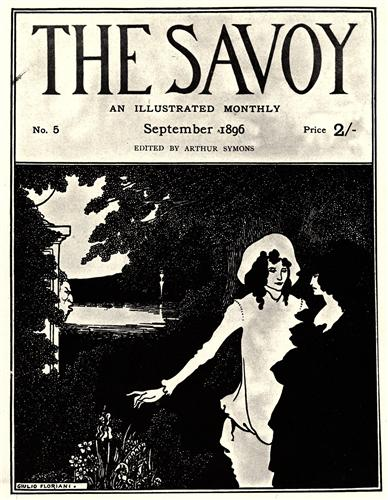Imagine the garden is a magical place. What fantastical creatures or elements could inhabit it, enhancing its charm and mystery? In this magical version of the garden, one might find enchanting creatures such as whispering will-o'-the-wisps floating near the river's edge, leading wanderers to hidden treasures. Majestic, iridescent butterflies with wings that sparkle like gemstones would flutter amongst the flowers. The trees could be home to wise old wood nymphs who watch over the garden, whispering secrets to those who listen closely. Beneath the surface of the sparkling river, mermaids with shimmering tails could be seen weaving through the water plants, occasionally breaking the surface to serenade the garden with their hauntingly beautiful songs. Magical flowers that bloom with the sunrise and glow softly in the moonlight could line the pathways, adding a touch of otherworldly beauty to this enchanted place. Each element would contribute to the garden's charm and mystery, making it a place of endless wonder and adventure. 